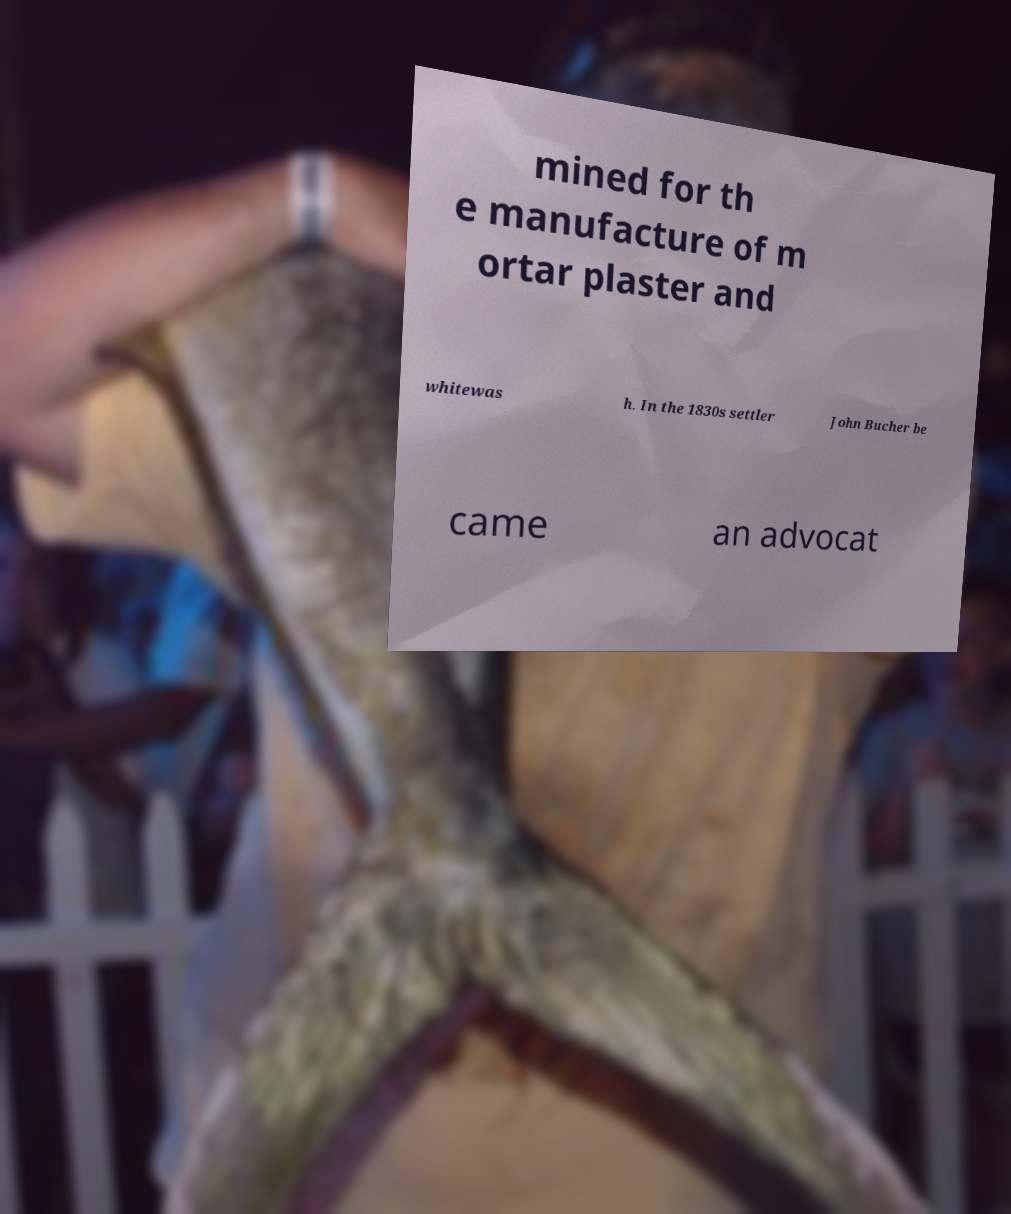There's text embedded in this image that I need extracted. Can you transcribe it verbatim? mined for th e manufacture of m ortar plaster and whitewas h. In the 1830s settler John Bucher be came an advocat 